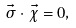Convert formula to latex. <formula><loc_0><loc_0><loc_500><loc_500>\vec { \sigma } \cdot \vec { \chi } = 0 ,</formula> 